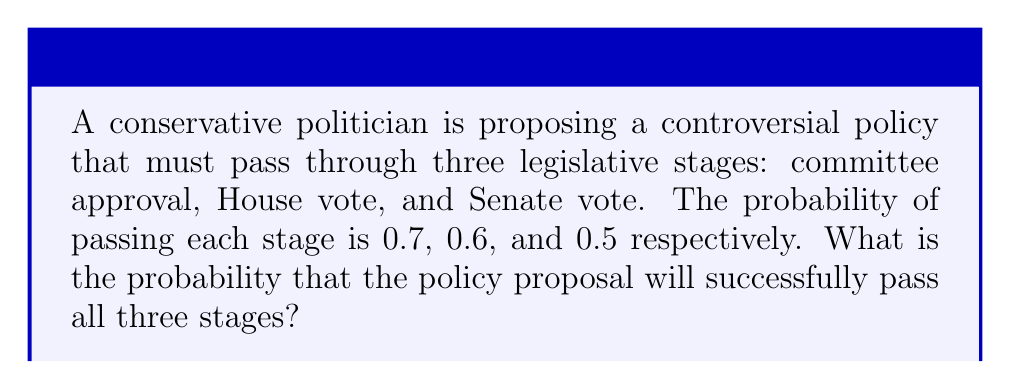Provide a solution to this math problem. To solve this problem, we need to use the multiplication rule of probability for independent events. Since each stage is independent of the others, we multiply the probabilities of success for each stage.

Let's define the events:
$A$: Passing committee approval (P(A) = 0.7)
$B$: Passing House vote (P(B) = 0.6)
$C$: Passing Senate vote (P(C) = 0.5)

The probability of the policy passing all three stages is:

$$P(A \cap B \cap C) = P(A) \times P(B) \times P(C)$$

Substituting the given probabilities:

$$P(A \cap B \cap C) = 0.7 \times 0.6 \times 0.5$$

Calculating:

$$P(A \cap B \cap C) = 0.21$$

Therefore, the probability of the policy proposal passing all three legislative stages is 0.21 or 21%.
Answer: 0.21 